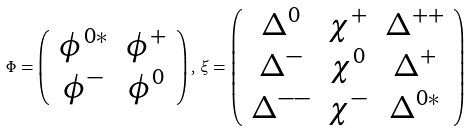<formula> <loc_0><loc_0><loc_500><loc_500>\Phi = \left ( \begin{array} { c c } \phi ^ { 0 * } & \phi ^ { + } \\ \phi ^ { - } & \phi ^ { 0 } \end{array} \right ) , \, \xi = \left ( \begin{array} { c c c } \Delta ^ { 0 } & \chi ^ { + } & \Delta ^ { + + } \\ \Delta ^ { - } & \chi ^ { 0 } & \Delta ^ { + } \\ \Delta ^ { - - } & \chi ^ { - } & \Delta ^ { 0 * } \end{array} \right )</formula> 